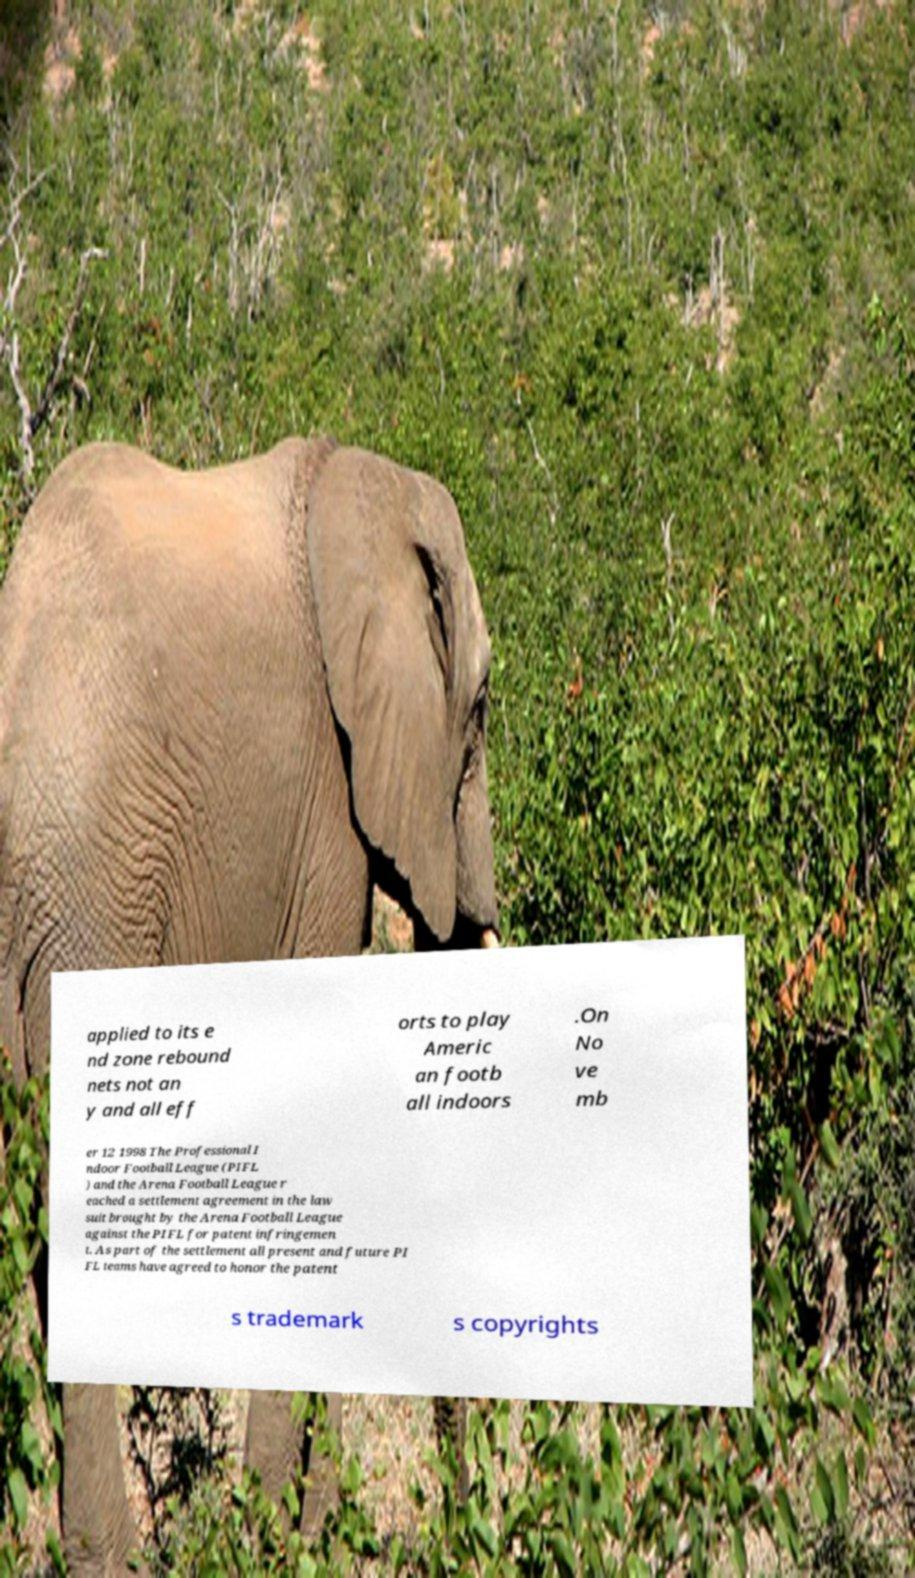Please read and relay the text visible in this image. What does it say? applied to its e nd zone rebound nets not an y and all eff orts to play Americ an footb all indoors .On No ve mb er 12 1998 The Professional I ndoor Football League (PIFL ) and the Arena Football League r eached a settlement agreement in the law suit brought by the Arena Football League against the PIFL for patent infringemen t. As part of the settlement all present and future PI FL teams have agreed to honor the patent s trademark s copyrights 